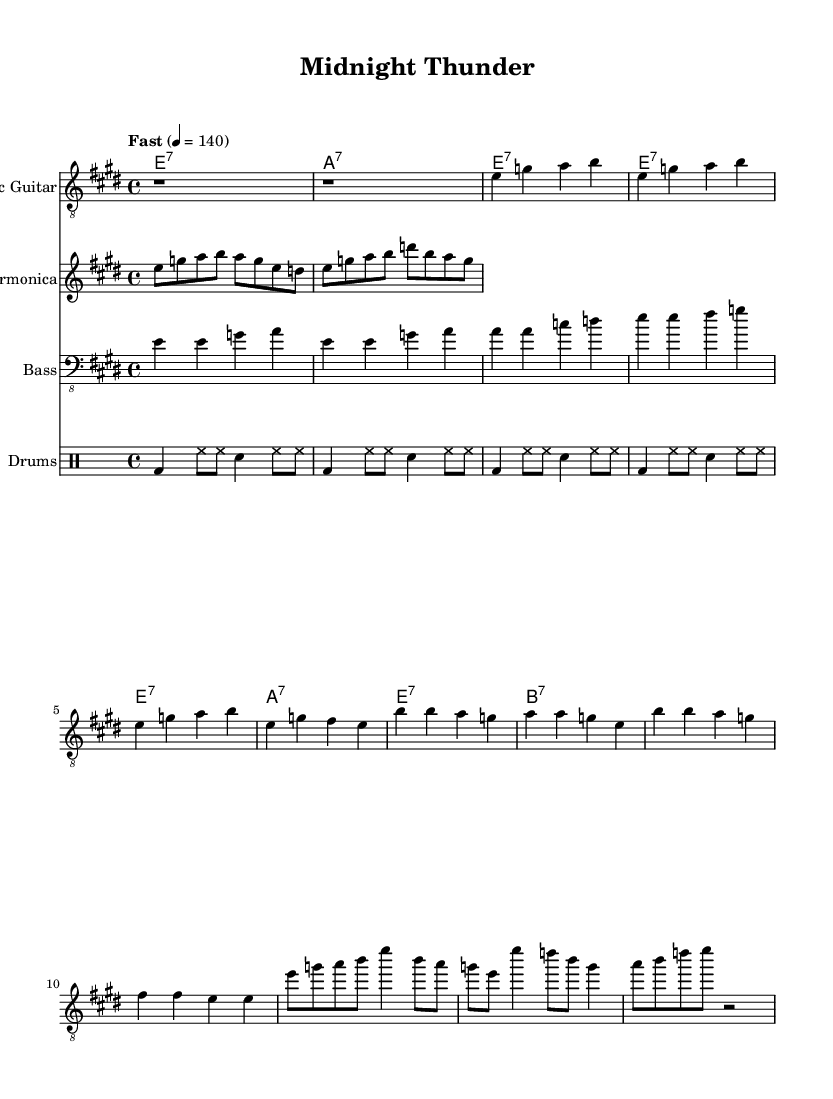What is the key signature of this music? The key signature is E major, which has four sharps (F#, C#, G#, D#). We can determine the key signature by looking at the beginning of the music where it states \key e \major.
Answer: E major What is the time signature of this music? The time signature is 4/4, indicating four beats per measure. This can be observed in the sheet music where it states \time 4/4.
Answer: 4/4 What is the tempo of this piece? The tempo marking indicates a fast speed of 140 beats per minute. This is shown as "Fast" 4 = 140 in the music sheet.
Answer: 140 How many measures are there in the guitar solo? The guitar solo section consists of 3 measures, indicated by the notes and rests. Counting all the segments of notes belonging to the solo confirms there are three distinct measures.
Answer: 3 What instruments are featured in this composition? The composition features Electric Guitar, Harmonica, Bass, and Drums. These instruments are specified by their names at the beginning of their respective staves.
Answer: Electric Guitar, Harmonica, Bass, Drums What is the chord progression for the chorus? The chord progression for the chorus consists of E7, A7, E7, and B7. This is determined by looking at the chords written next to the respective measures in the chorus section of the sheet music.
Answer: E7, A7, E7, B7 